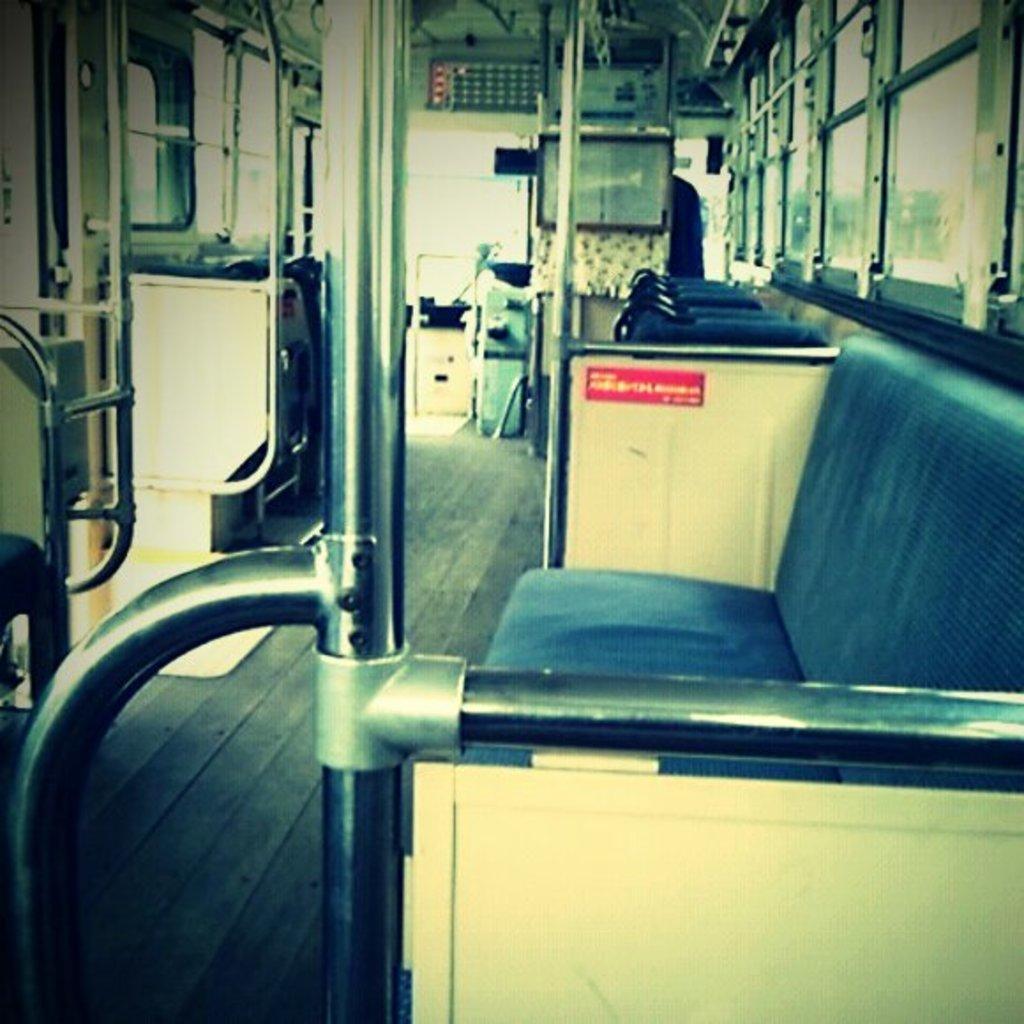How would you summarize this image in a sentence or two? This is an inside view of a vehicle. On the right side, I can see the chairs and the windows. In front of the cars there are two poles. In the background some other seats and I can see the windows. 